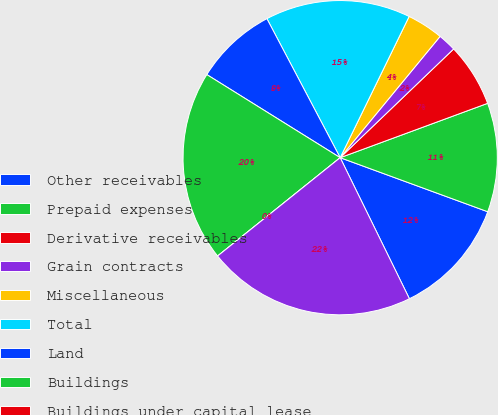Convert chart. <chart><loc_0><loc_0><loc_500><loc_500><pie_chart><fcel>Other receivables<fcel>Prepaid expenses<fcel>Derivative receivables<fcel>Grain contracts<fcel>Miscellaneous<fcel>Total<fcel>Land<fcel>Buildings<fcel>Buildings under capital lease<fcel>Equipment<nl><fcel>12.15%<fcel>11.21%<fcel>6.54%<fcel>1.87%<fcel>3.74%<fcel>14.95%<fcel>8.41%<fcel>19.63%<fcel>0.0%<fcel>21.5%<nl></chart> 